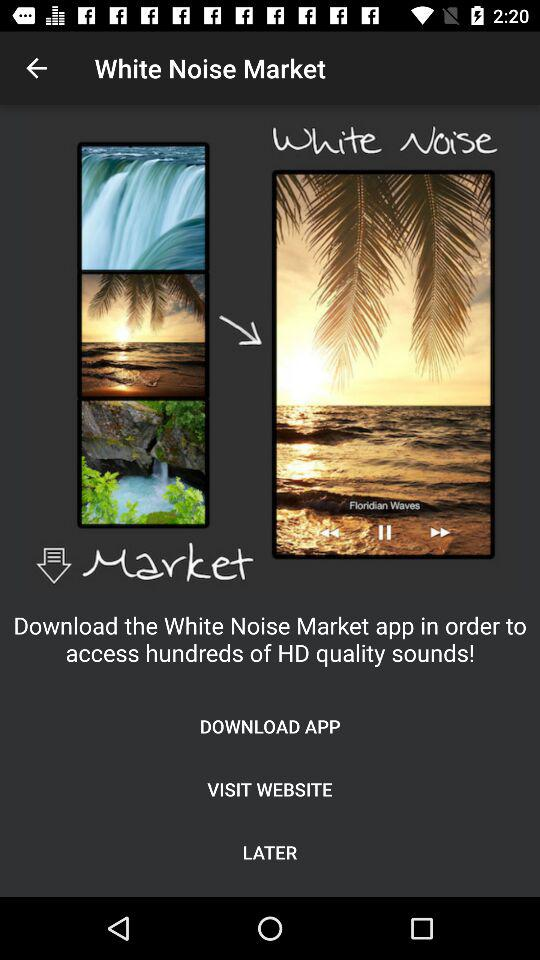How to access hundreds of HD quality sounds? To access hundreds of HD quality sounds, download the "White Noise Market" app. 